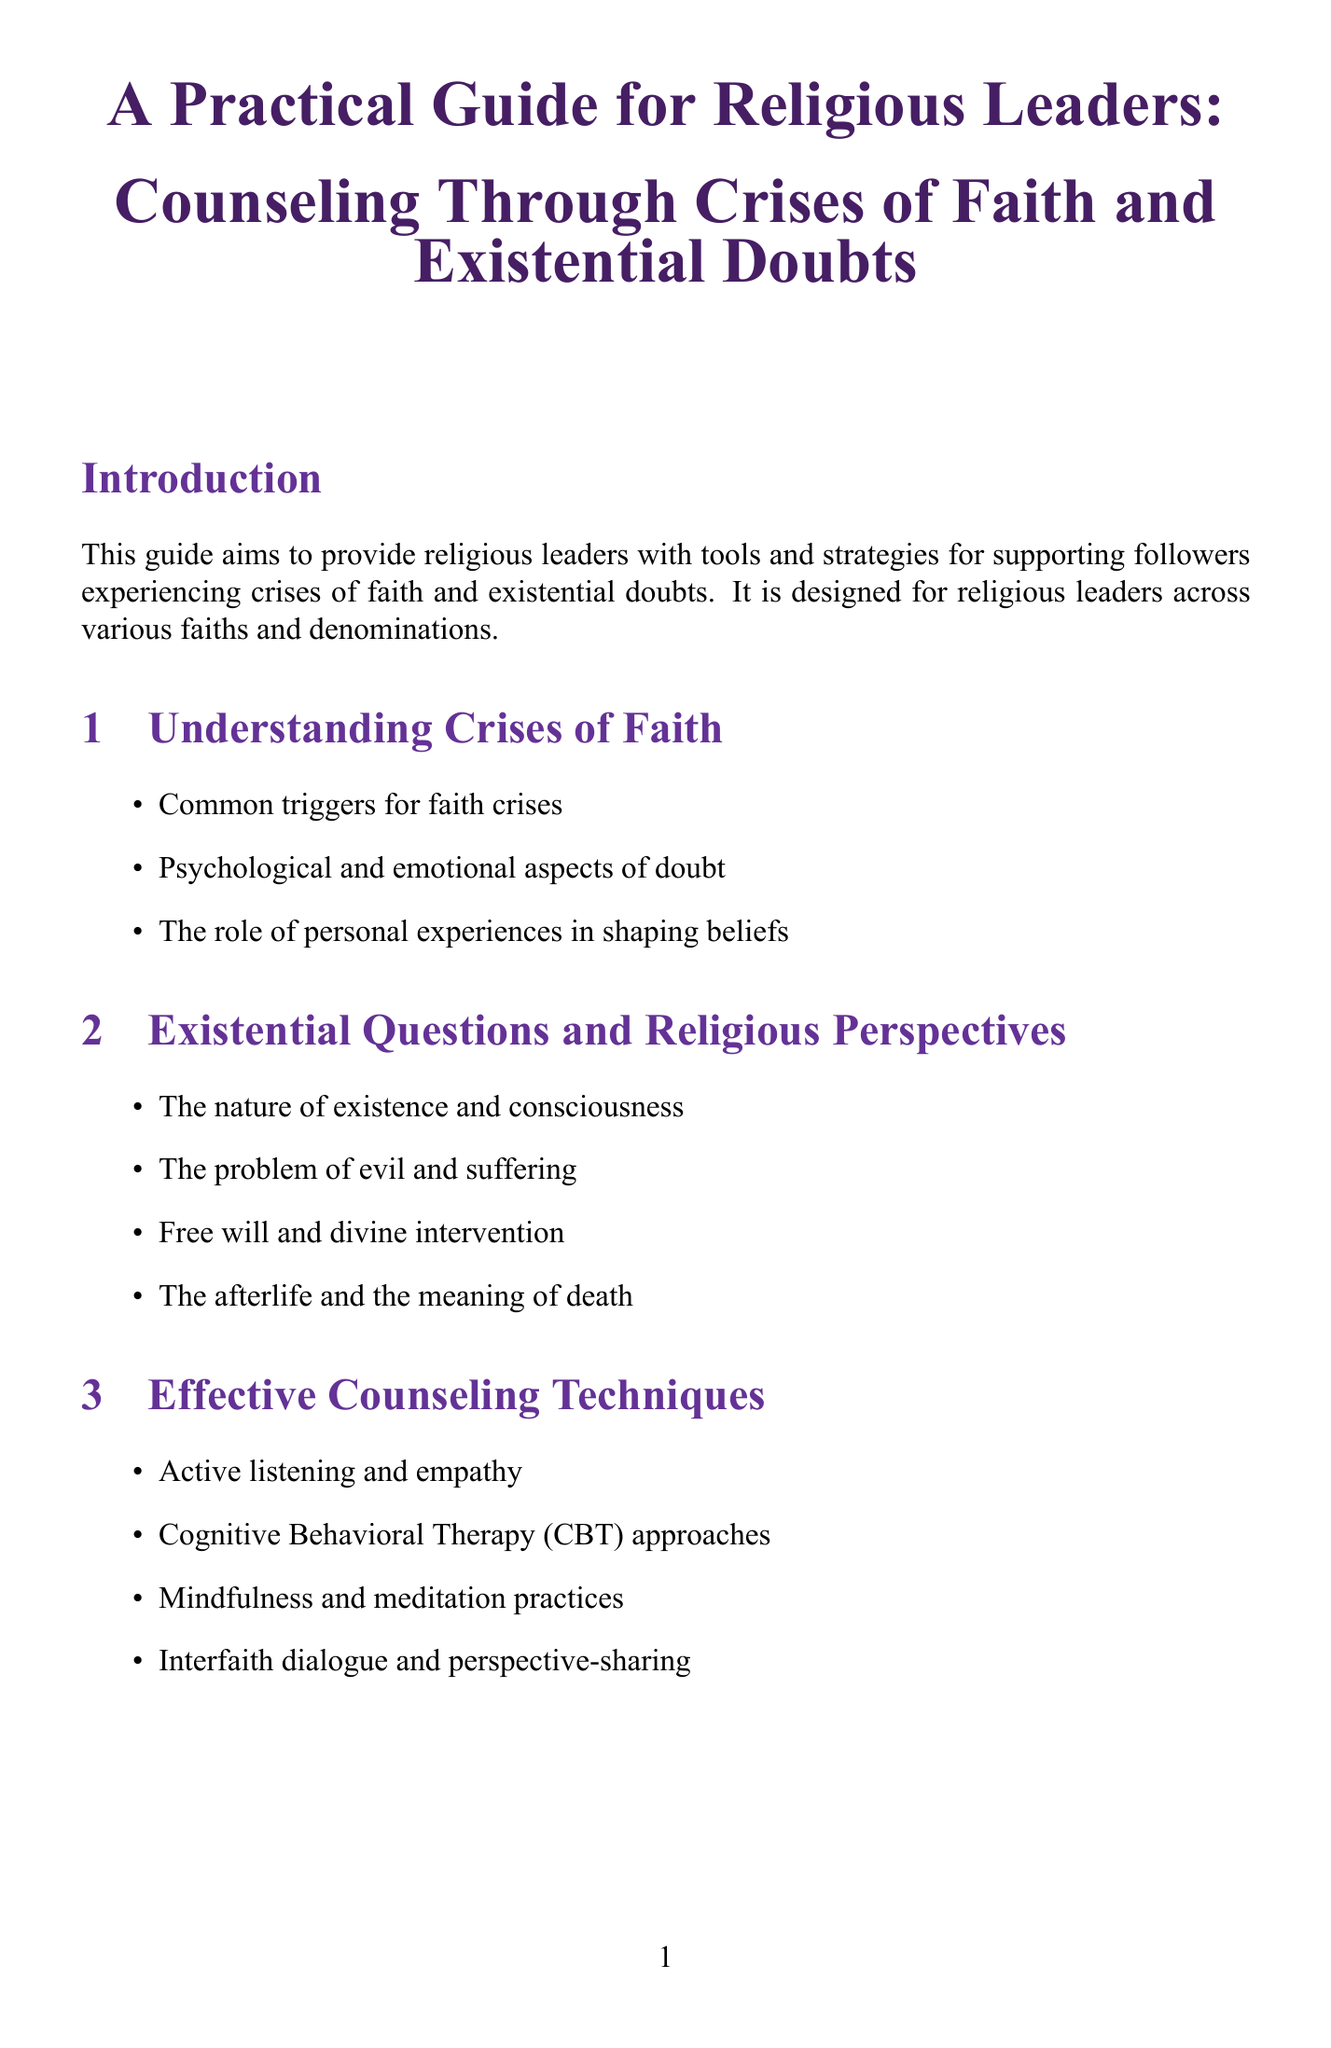What is the purpose of the guide? The purpose of the guide is to provide religious leaders with tools and strategies for supporting followers experiencing crises of faith and existential doubts.
Answer: To provide religious leaders with tools and strategies for supporting followers experiencing crises of faith and existential doubts How many chapters are in the guide? The document lists six chapters for counseling through crises of faith and existential doubts.
Answer: Six What is included in the chapter on Effective Counseling Techniques? This chapter contains sections on active listening, cognitive behavioral therapy approaches, mindfulness practices, and perspective sharing.
Answer: Active listening and empathy, Cognitive Behavioral Therapy (CBT) approaches, Mindfulness and meditation practices, Interfaith dialogue and perspective-sharing Which book discusses the problem of evil? Since the recommended reading includes books but does not specify topics per book, this question focuses on exploring the suggested materials indirectly connected to the issue addressed.
Answer: The Case for Faith by Lee Strobel What are key takeaways from the conclusion? Key takeaways include embracing doubt as a natural part of faith development, encouraging open dialogue, and providing a safe space for exploration.
Answer: Embrace doubt as a natural part of faith development What is one example of a case study presented? The document provides several real-world examples of individuals' crises of faith.
Answer: The story of Mother Teresa's crisis of faith What online resource focuses on philosophy? The online resources listed include various websites, and one particularly emphasizes philosophical insights.
Answer: Stanford Encyclopedia of Philosophy 